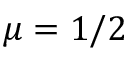<formula> <loc_0><loc_0><loc_500><loc_500>\mu = 1 / 2</formula> 